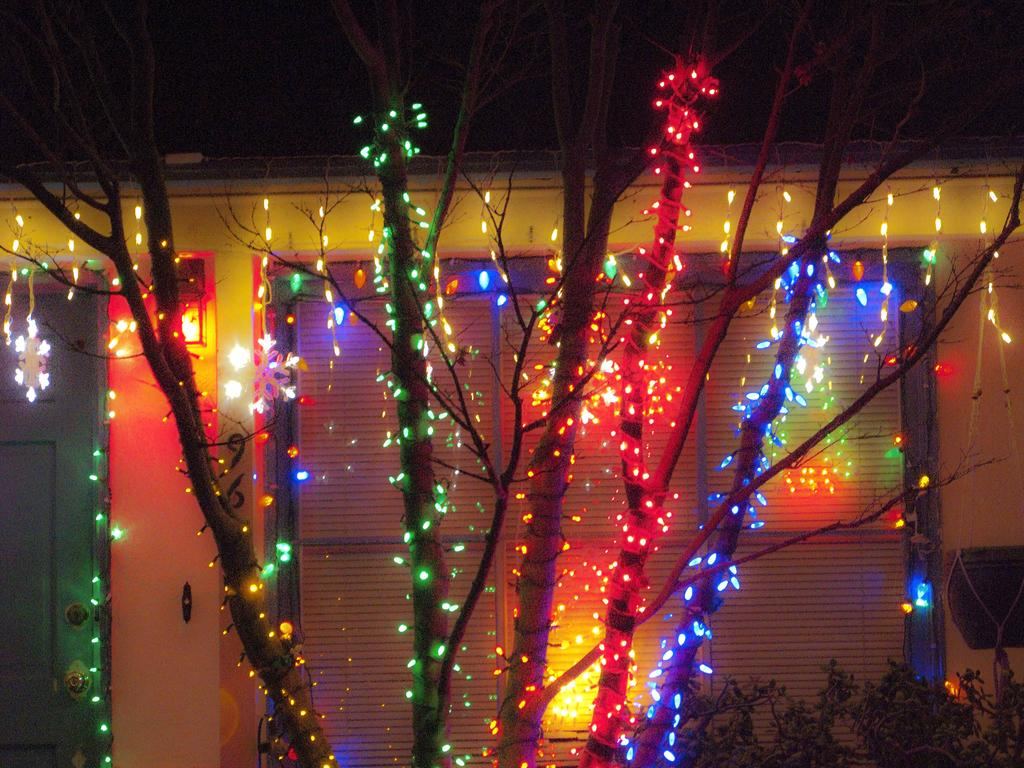What type of decoration is present on the trees in the image? There are lights on the trees in the image. What other types of vegetation can be seen in the image? There are plants in the image. What can be seen in the background of the image? There is a wall, a door, and a window in the background of the image. What type of beast can be heard whistling in the image? There is no beast or whistling present in the image. What is the interest of the plants in the image? Plants do not have interests; they are inanimate objects. 